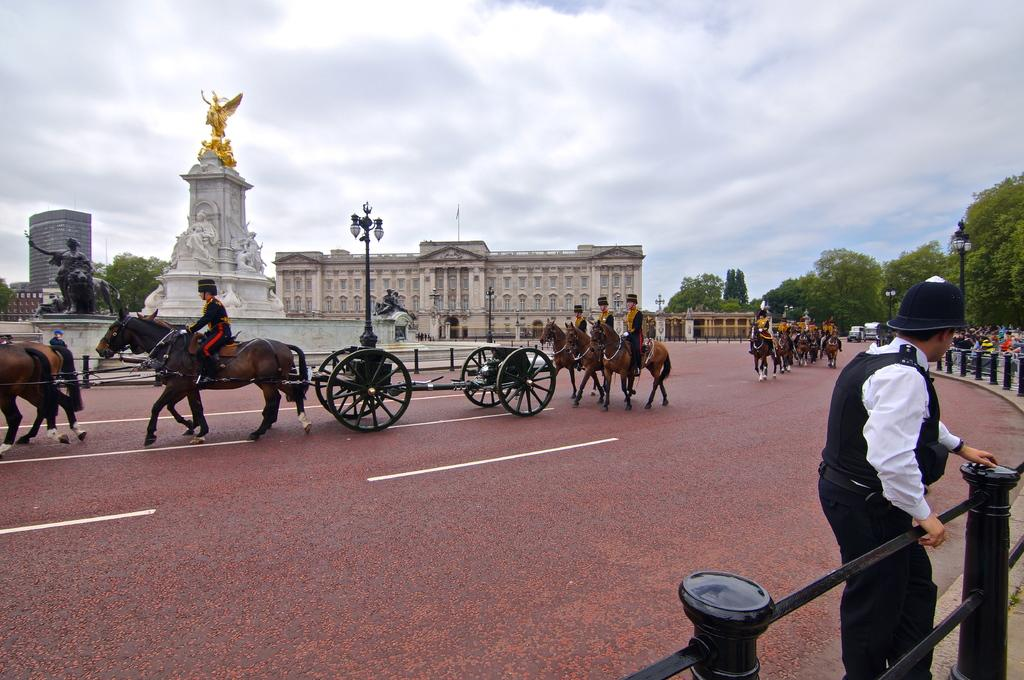What is the man in the image doing? The man is sitting on a horse in the image. Who else is present in the image besides the man on the horse? There is a person standing in the image. How many horses are visible in the image? There are multiple horses in the image. What can be seen in the background of the image? Trees, a building, and a statue are visible at the back of the image. What verse is being recited by the horse in the image? There is no indication that any verse is being recited in the image, as it features a man sitting on a horse and other people and objects. Is there a playground visible in the image? There is no mention of a playground in the provided facts, and therefore it cannot be determined if one is present in the image. 